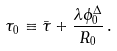Convert formula to latex. <formula><loc_0><loc_0><loc_500><loc_500>\tau _ { 0 } \equiv \bar { \tau } + \frac { \lambda \phi ^ { \Delta } _ { 0 } } { R _ { 0 } } \, .</formula> 